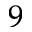Convert formula to latex. <formula><loc_0><loc_0><loc_500><loc_500>_ { 9 }</formula> 